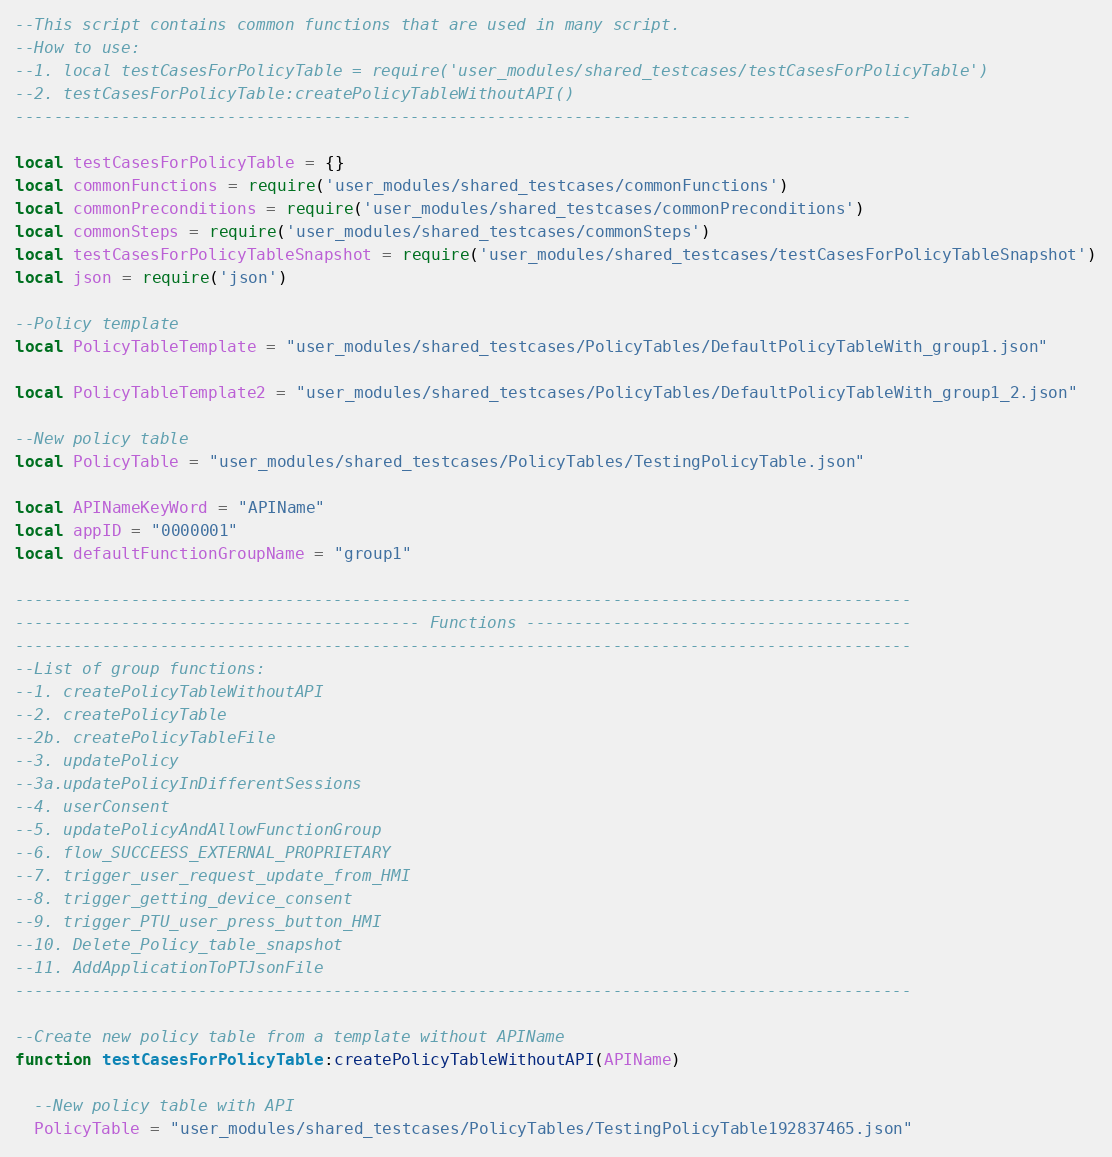<code> <loc_0><loc_0><loc_500><loc_500><_Lua_>--This script contains common functions that are used in many script.
--How to use:
--1. local testCasesForPolicyTable = require('user_modules/shared_testcases/testCasesForPolicyTable')
--2. testCasesForPolicyTable:createPolicyTableWithoutAPI()
---------------------------------------------------------------------------------------------

local testCasesForPolicyTable = {}
local commonFunctions = require('user_modules/shared_testcases/commonFunctions')
local commonPreconditions = require('user_modules/shared_testcases/commonPreconditions')
local commonSteps = require('user_modules/shared_testcases/commonSteps')
local testCasesForPolicyTableSnapshot = require('user_modules/shared_testcases/testCasesForPolicyTableSnapshot')
local json = require('json')

--Policy template
local PolicyTableTemplate = "user_modules/shared_testcases/PolicyTables/DefaultPolicyTableWith_group1.json"

local PolicyTableTemplate2 = "user_modules/shared_testcases/PolicyTables/DefaultPolicyTableWith_group1_2.json"

--New policy table
local PolicyTable = "user_modules/shared_testcases/PolicyTables/TestingPolicyTable.json"

local APINameKeyWord = "APIName"
local appID = "0000001"
local defaultFunctionGroupName = "group1"

---------------------------------------------------------------------------------------------
------------------------------------------ Functions ----------------------------------------
---------------------------------------------------------------------------------------------
--List of group functions:
--1. createPolicyTableWithoutAPI
--2. createPolicyTable
--2b. createPolicyTableFile
--3. updatePolicy
--3a.updatePolicyInDifferentSessions
--4. userConsent
--5. updatePolicyAndAllowFunctionGroup
--6. flow_SUCCEESS_EXTERNAL_PROPRIETARY
--7. trigger_user_request_update_from_HMI
--8. trigger_getting_device_consent
--9. trigger_PTU_user_press_button_HMI
--10. Delete_Policy_table_snapshot
--11. AddApplicationToPTJsonFile
---------------------------------------------------------------------------------------------

--Create new policy table from a template without APIName
function testCasesForPolicyTable:createPolicyTableWithoutAPI(APIName)

  --New policy table with API
  PolicyTable = "user_modules/shared_testcases/PolicyTables/TestingPolicyTable192837465.json"
</code> 